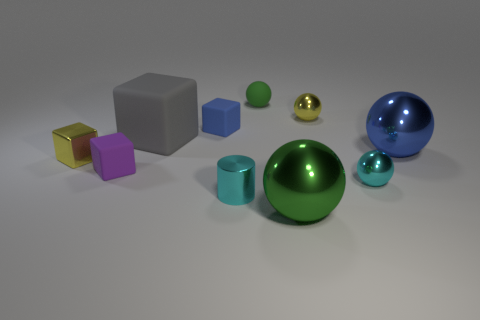Subtract all blue balls. How many balls are left? 4 Subtract all small cyan balls. How many balls are left? 4 Subtract all brown spheres. Subtract all yellow blocks. How many spheres are left? 5 Subtract all cylinders. How many objects are left? 9 Add 1 tiny yellow metallic spheres. How many tiny yellow metallic spheres are left? 2 Add 9 tiny red metal spheres. How many tiny red metal spheres exist? 9 Subtract 0 brown spheres. How many objects are left? 10 Subtract all metallic things. Subtract all small green matte objects. How many objects are left? 3 